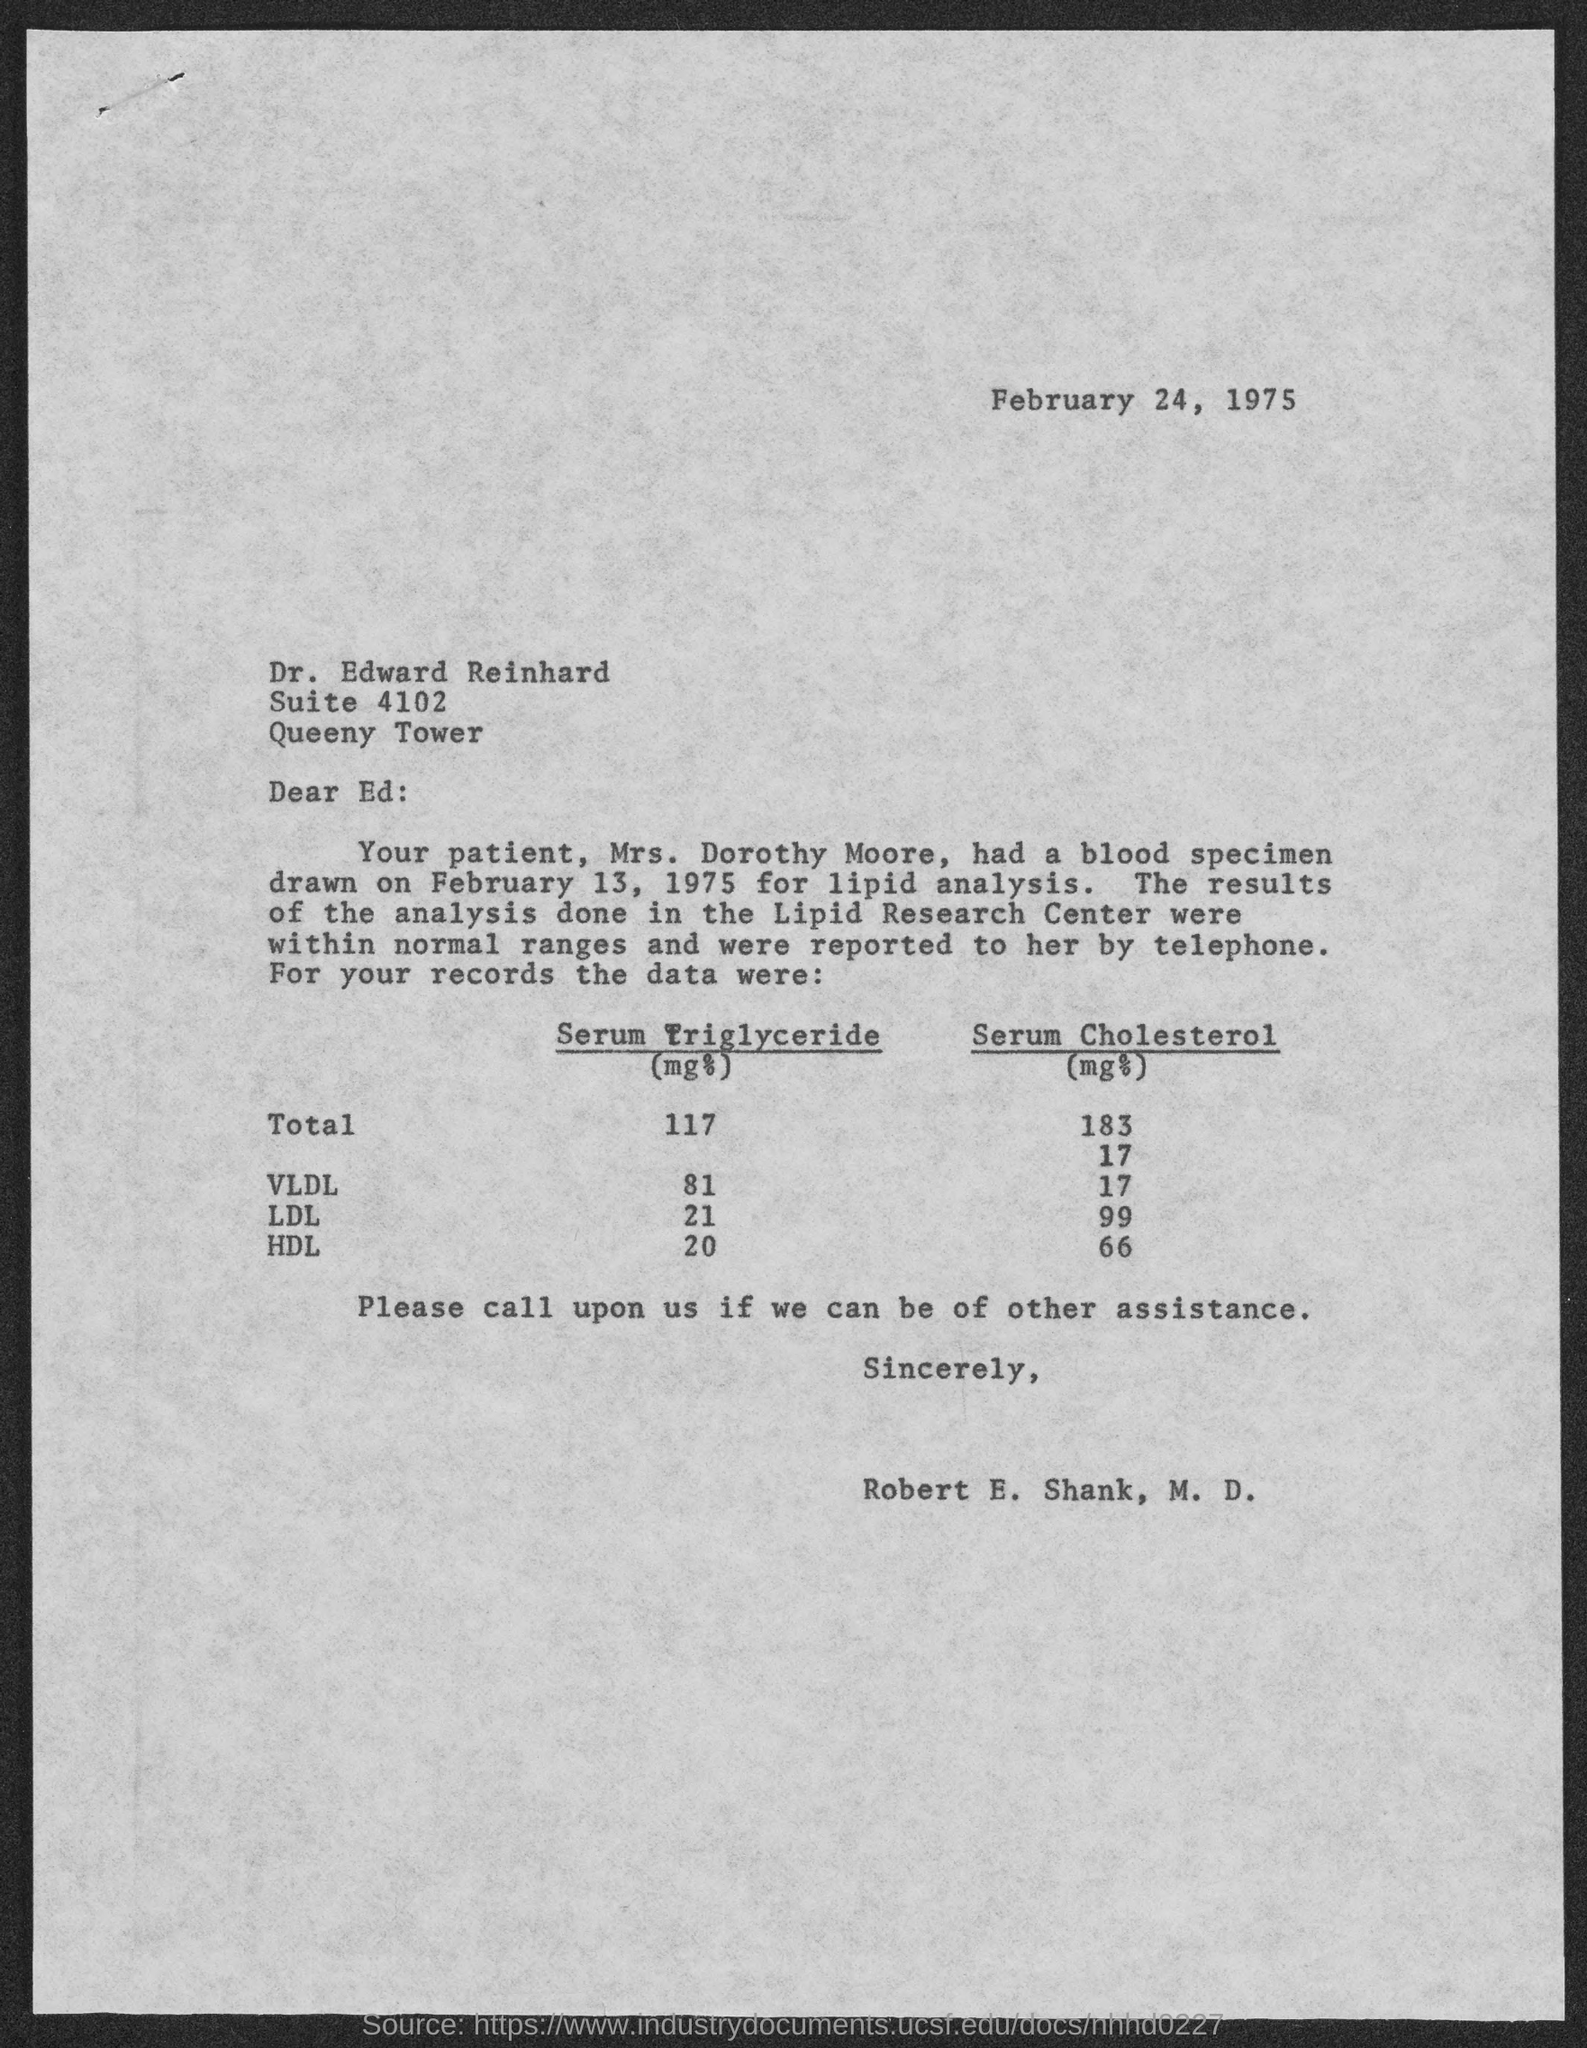What is the date mentioned in the top of the document ?
Keep it short and to the point. February 24, 1975. What is the Suite Number ?
Ensure brevity in your answer.  4102. Who is the Memorandum from ?
Give a very brief answer. Robert E. Shank, M. D. Who is the Memorandum addressed to ?
Your answer should be compact. Ed. How much Serum Cholesterol of VLDL ?
Provide a short and direct response. 17. 